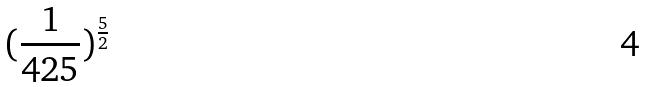<formula> <loc_0><loc_0><loc_500><loc_500>( \frac { 1 } { 4 2 5 } ) ^ { \frac { 5 } { 2 } }</formula> 